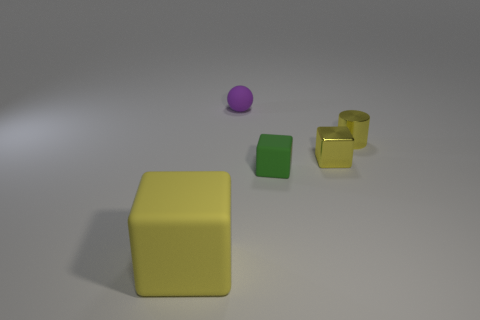Subtract all large yellow rubber blocks. How many blocks are left? 2 Add 2 tiny gray metallic balls. How many objects exist? 7 Subtract all yellow blocks. How many blocks are left? 1 Subtract 1 balls. How many balls are left? 0 Subtract all green cylinders. How many green cubes are left? 1 Subtract all tiny metal cubes. Subtract all tiny cubes. How many objects are left? 2 Add 2 small yellow cylinders. How many small yellow cylinders are left? 3 Add 1 small gray matte cylinders. How many small gray matte cylinders exist? 1 Subtract 0 purple cubes. How many objects are left? 5 Subtract all cylinders. How many objects are left? 4 